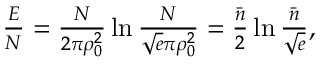Convert formula to latex. <formula><loc_0><loc_0><loc_500><loc_500>\begin{array} { r } { \frac { E } { N } = \frac { N } 2 \pi \rho _ { 0 } ^ { 2 } } \ln \frac { N } { \sqrt { e } \pi \rho _ { 0 } ^ { 2 } } = \frac { \bar { n } } { 2 } \ln \frac { \bar { n } } { \sqrt { e } } , } \end{array}</formula> 